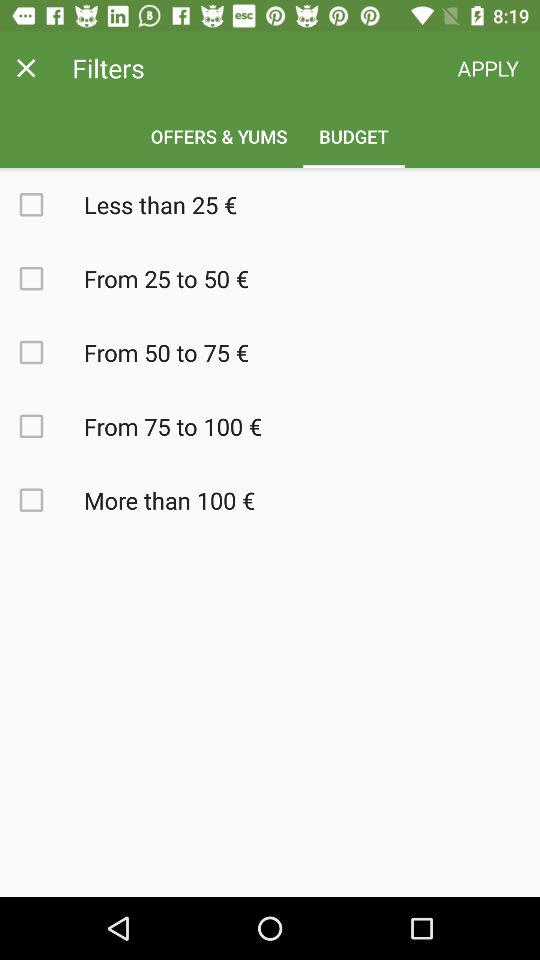Which tab is selected? The selected tab is "BUDGET". 